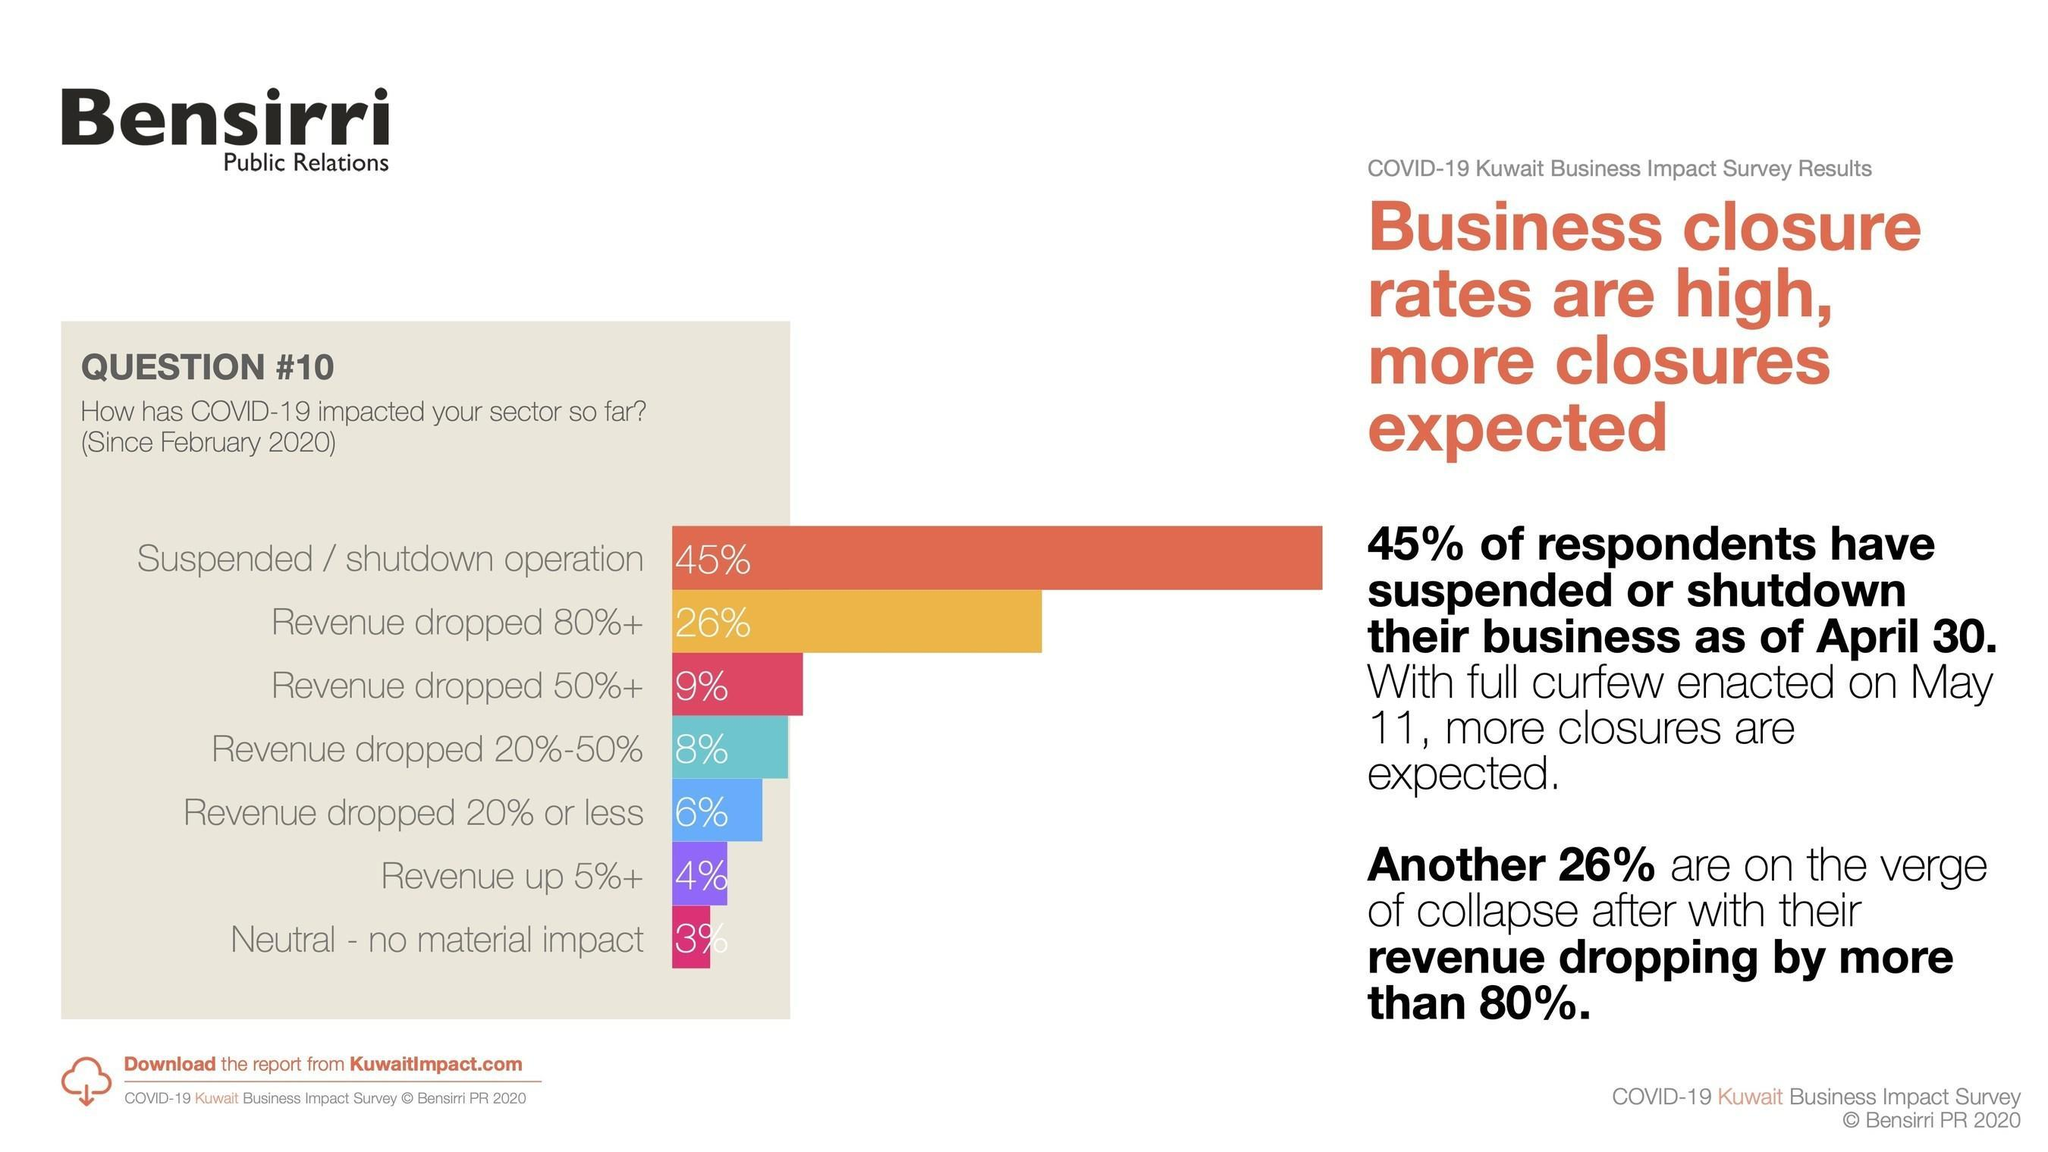What is the total percentage of businesses whose revenue has gone down by 50% or less?
Answer the question with a short phrase. 14% What is the total percentage of businesses whose revenue has not dropped? 7% 